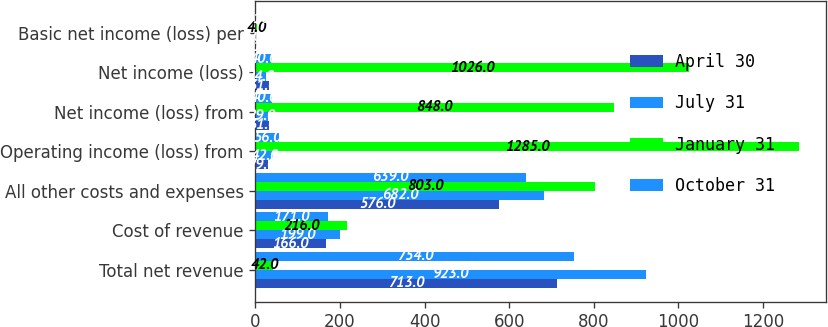Convert chart to OTSL. <chart><loc_0><loc_0><loc_500><loc_500><stacked_bar_chart><ecel><fcel>Total net revenue<fcel>Cost of revenue<fcel>All other costs and expenses<fcel>Operating income (loss) from<fcel>Net income (loss) from<fcel>Net income (loss)<fcel>Basic net income (loss) per<nl><fcel>April 30<fcel>713<fcel>166<fcel>576<fcel>29<fcel>31<fcel>31<fcel>0.11<nl><fcel>July 31<fcel>923<fcel>199<fcel>682<fcel>42<fcel>29<fcel>24<fcel>0.09<nl><fcel>January 31<fcel>42<fcel>216<fcel>803<fcel>1285<fcel>848<fcel>1026<fcel>4<nl><fcel>October 31<fcel>754<fcel>171<fcel>639<fcel>56<fcel>40<fcel>40<fcel>0.16<nl></chart> 